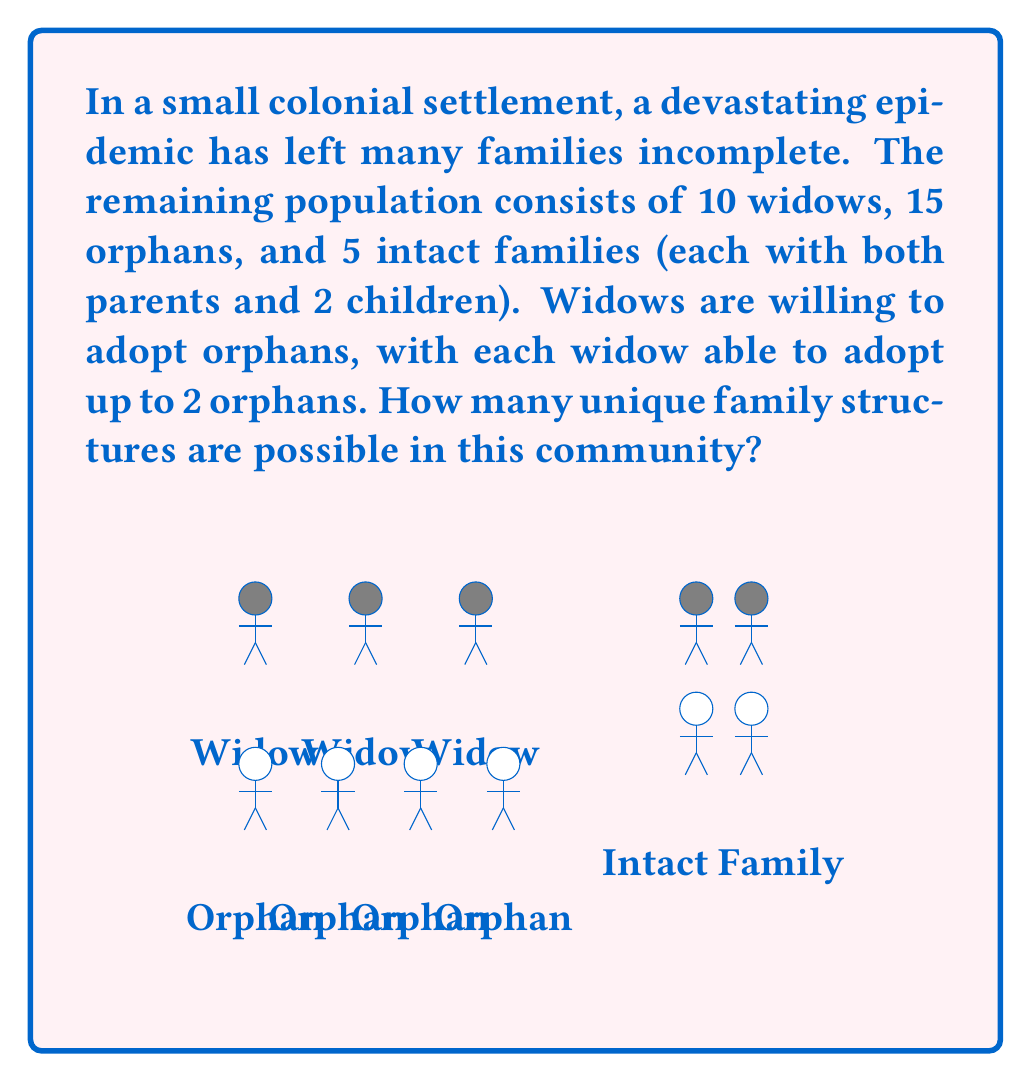Show me your answer to this math problem. Let's approach this step-by-step:

1) First, we need to consider how many orphans can be adopted:
   - 10 widows can adopt up to 20 orphans (2 each)
   - There are only 15 orphans available
   - So all orphans can potentially be adopted

2) Now, we need to calculate the number of ways to distribute 15 orphans among 10 widows, where each widow can adopt 0, 1, or 2 orphans.

3) This is a classic stars and bars problem. We can think of it as distributing 15 identical objects (orphans) into 10 distinct boxes (widows), where each box can hold up to 2 objects.

4) The generating function for this problem is:
   $$(1 + x + x^2)^{10}$$
   where the coefficient of $x^{15}$ gives us the number of ways to distribute 15 orphans.

5) Expanding this polynomial and finding the coefficient of $x^{15}$ is computationally intensive, so we'll use a combinatorial approach.

6) We can use the principle of inclusion-exclusion:
   Let $a_i$ be the number of distributions where at least $i$ widows adopt more than 2 orphans.
   
   $$a_0 = \binom{24}{15}$$ (total ways to distribute 15 indistinguishable objects into 10 distinguishable boxes)
   
   $$a_1 = \binom{10}{1}\binom{22}{13}$$
   
   $$a_2 = \binom{10}{2}\binom{20}{11}$$
   
   $$a_3 = \binom{10}{3}\binom{18}{9}$$
   
   $$a_4 = \binom{10}{4}\binom{16}{7}$$
   
   $$a_5 = \binom{10}{5}\binom{14}{5}$$

7) The number of valid distributions is:

   $$a_0 - a_1 + a_2 - a_3 + a_4 - a_5 = 1,961,256$$

8) Finally, we need to account for the 5 intact families, which don't change. So the total number of unique family structures is just this single number.
Answer: 1,961,256 